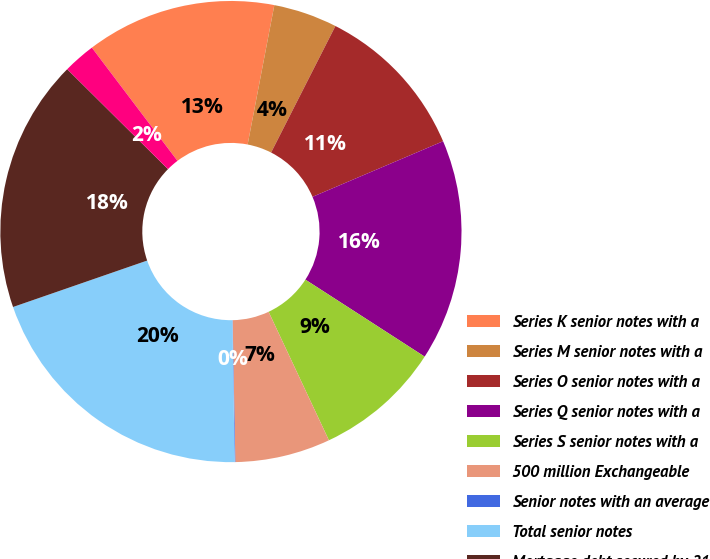Convert chart. <chart><loc_0><loc_0><loc_500><loc_500><pie_chart><fcel>Series K senior notes with a<fcel>Series M senior notes with a<fcel>Series O senior notes with a<fcel>Series Q senior notes with a<fcel>Series S senior notes with a<fcel>500 million Exchangeable<fcel>Senior notes with an average<fcel>Total senior notes<fcel>Mortgage debt secured by 21<fcel>Other<nl><fcel>13.32%<fcel>4.47%<fcel>11.11%<fcel>15.53%<fcel>8.89%<fcel>6.68%<fcel>0.05%<fcel>19.95%<fcel>17.74%<fcel>2.26%<nl></chart> 